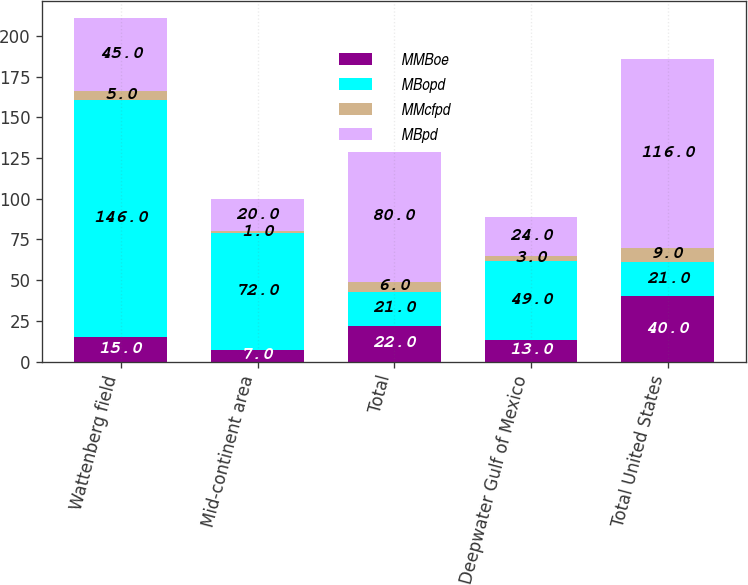<chart> <loc_0><loc_0><loc_500><loc_500><stacked_bar_chart><ecel><fcel>Wattenberg field<fcel>Mid-continent area<fcel>Total<fcel>Deepwater Gulf of Mexico<fcel>Total United States<nl><fcel>MMBoe<fcel>15<fcel>7<fcel>22<fcel>13<fcel>40<nl><fcel>MBopd<fcel>146<fcel>72<fcel>21<fcel>49<fcel>21<nl><fcel>MMcfpd<fcel>5<fcel>1<fcel>6<fcel>3<fcel>9<nl><fcel>MBpd<fcel>45<fcel>20<fcel>80<fcel>24<fcel>116<nl></chart> 